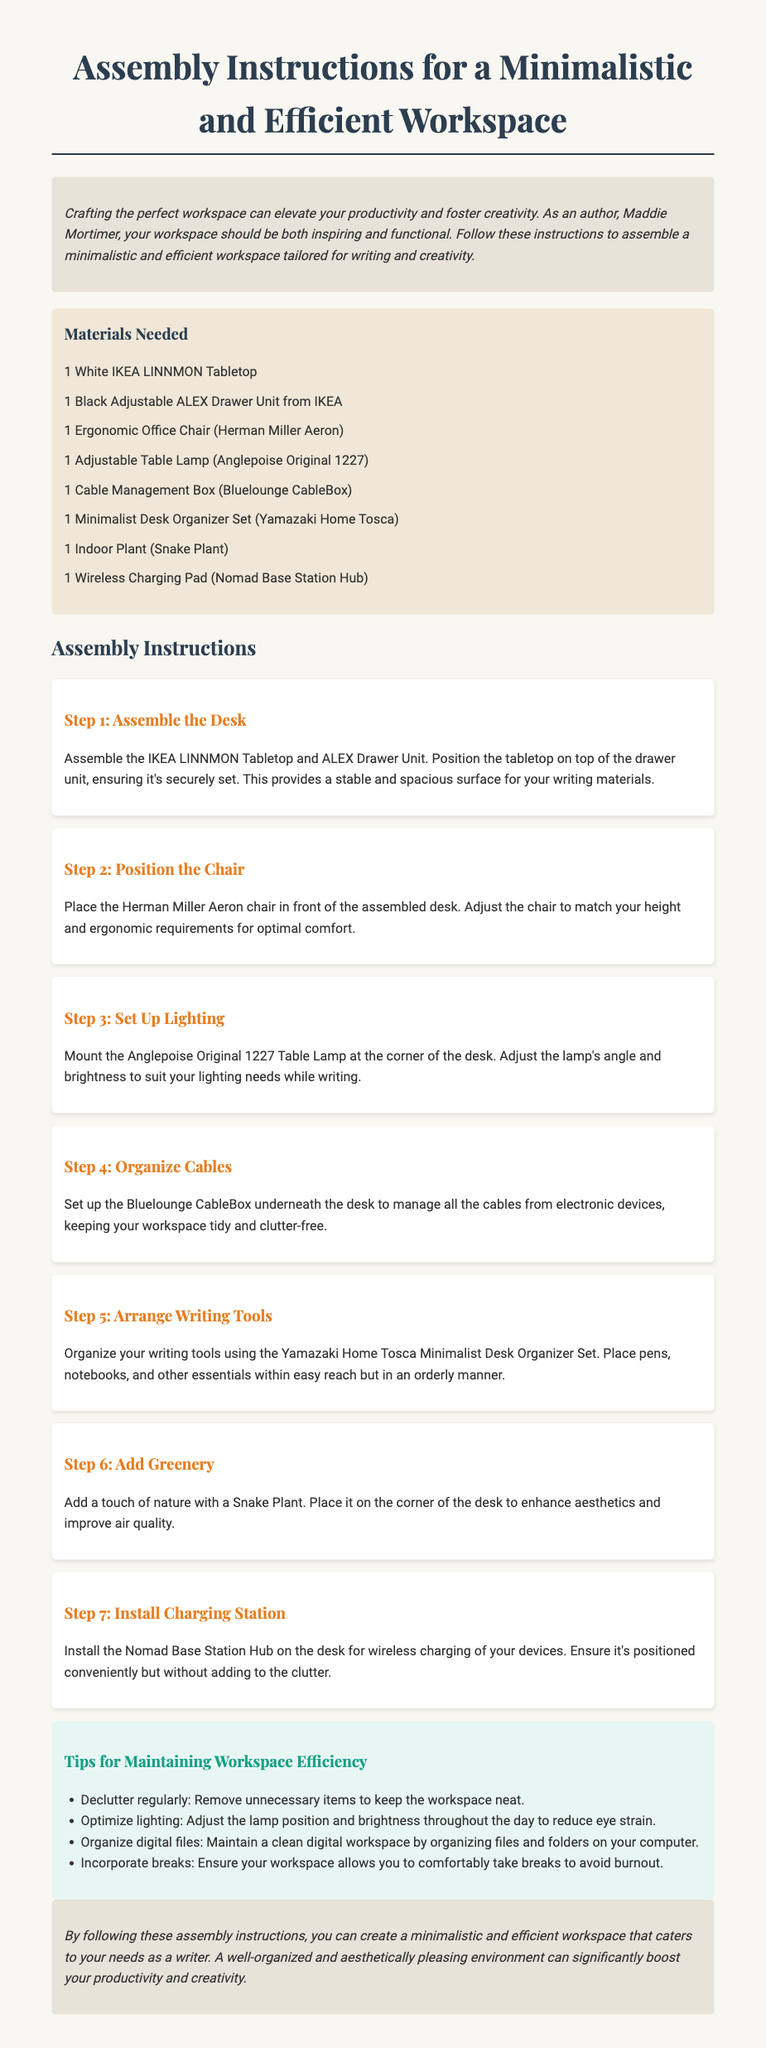What is the title of the document? The title is stated in the header of the document, which reinforces the main purpose.
Answer: Assembly Instructions for a Minimalistic and Efficient Workspace How many materials are needed? The materials needed are listed under a specific section that provides a clear count of items.
Answer: 8 What type of chair is recommended? The chair is mentioned in the materials list, indicating a specific ergonomic model for comfort.
Answer: Herman Miller Aeron What step involves organizing writing tools? Each step is numbered and outlines specific tasks; this step focuses on arranging tools for efficiency.
Answer: Arrange Writing Tools What is one tip for maintaining workspace efficiency? Tips are provided to enhance workspace productivity, highlighting key best practices.
Answer: Declutter regularly What positioning is recommended for the cable management box? The positioning is described in the assembly steps where cleanliness is emphasized.
Answer: Underneath the desk What type of lamp is suggested for the workspace? The lamp is specifically identified in the materials list, tying functionality to the workspace setup.
Answer: Anglepoise Original 1227 What indoor plant is recommended to enhance aesthetics? The plant is mentioned as a key addition to the workspace for both beauty and health.
Answer: Snake Plant 